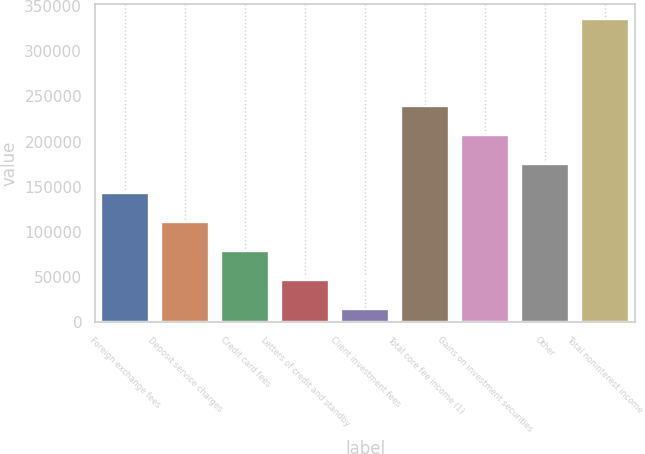Convert chart. <chart><loc_0><loc_0><loc_500><loc_500><bar_chart><fcel>Foreign exchange fees<fcel>Deposit service charges<fcel>Credit card fees<fcel>Letters of credit and standby<fcel>Client investment fees<fcel>Total core fee income (1)<fcel>Gains on investment securities<fcel>Other<fcel>Total noninterest income<nl><fcel>142942<fcel>110841<fcel>78740.4<fcel>46639.7<fcel>14539<fcel>239244<fcel>207143<fcel>175042<fcel>335546<nl></chart> 